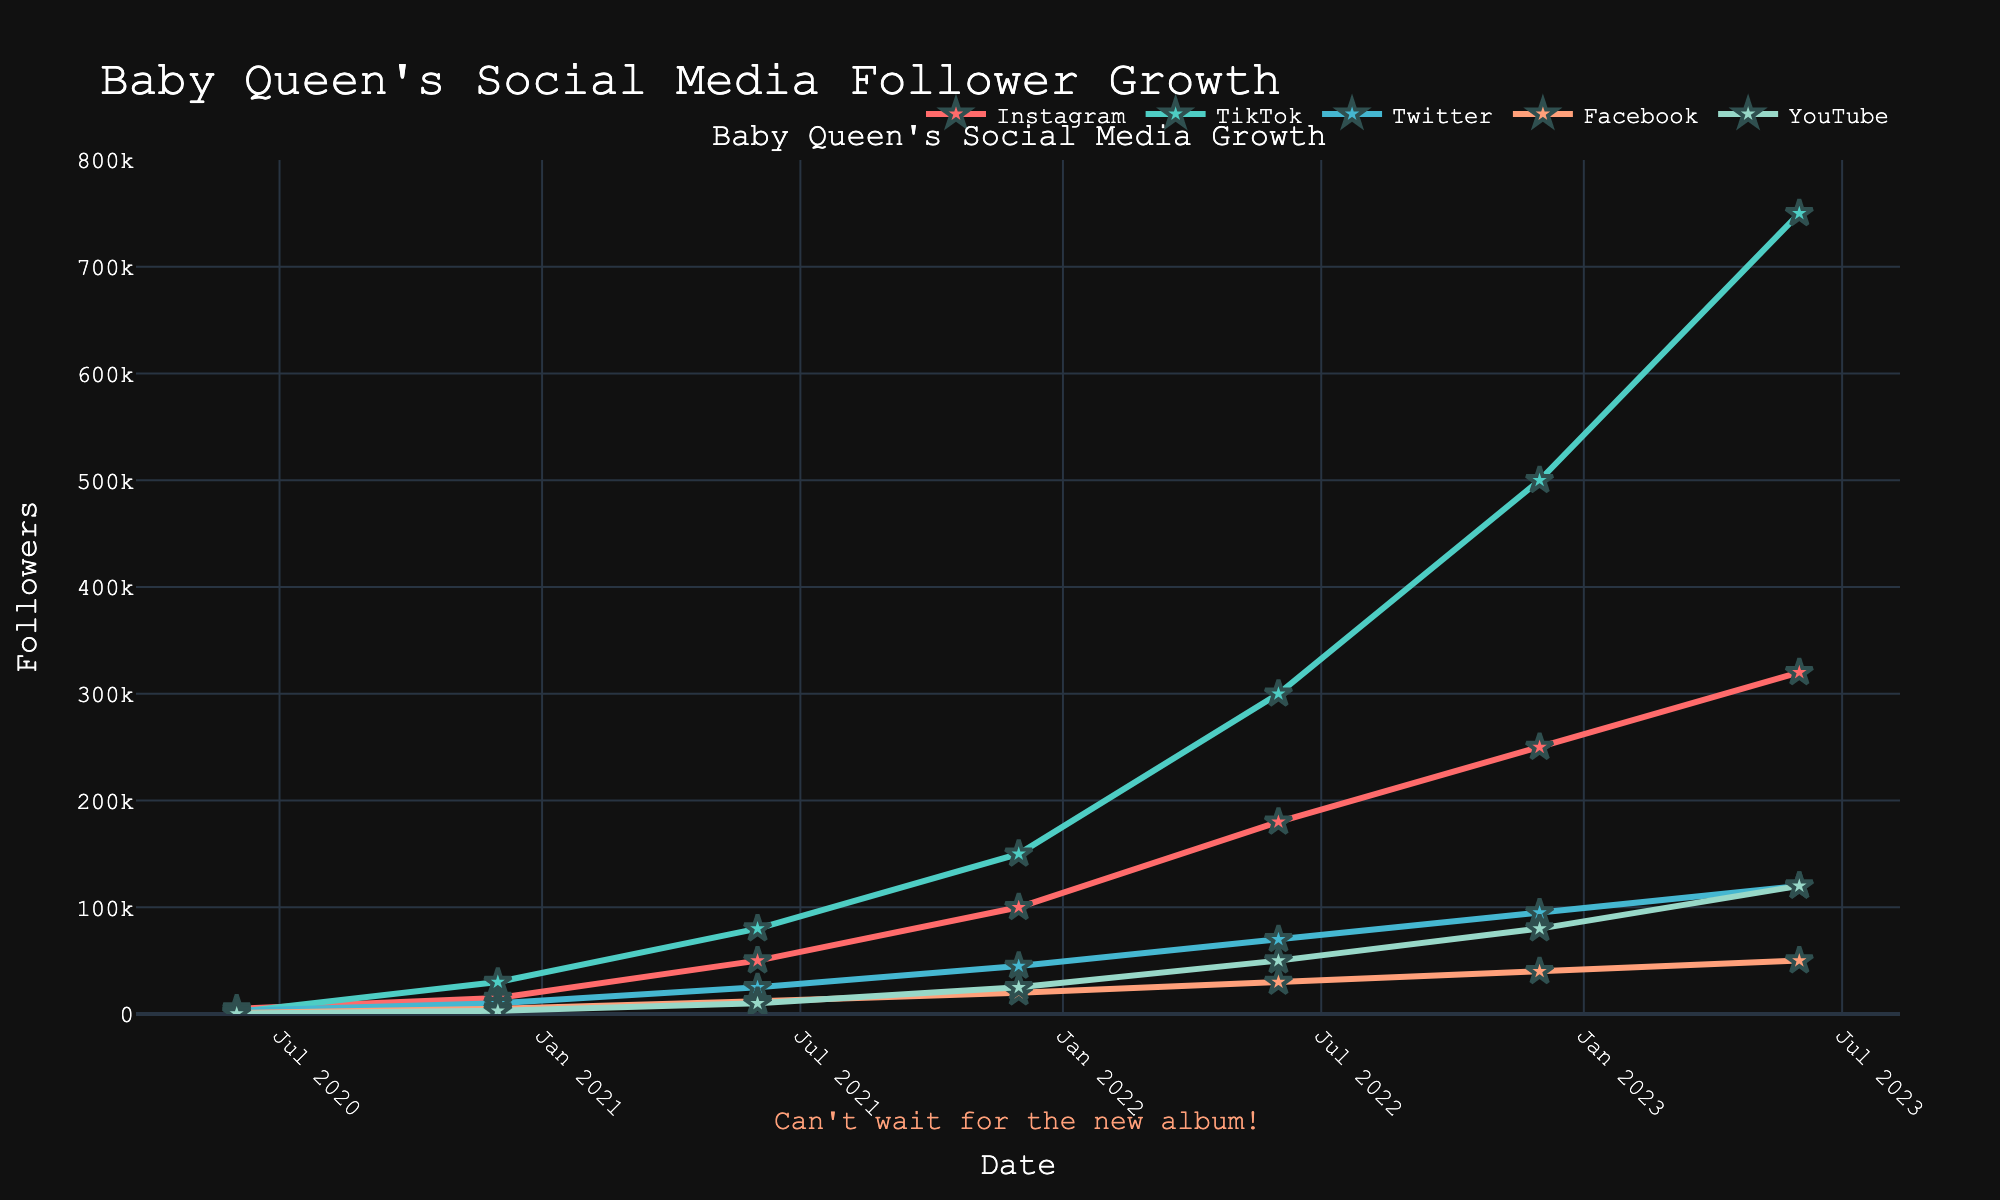which platform had the most followers by June 2023? Look at the endpoints of the lines in June 2023 and find which one is the highest. TikTok is at 750,000 followers, the highest among all.
Answer: TikTok how many new followers did YouTube gain from December 2020 to December 2022? Check the YouTube followers at both dates: 3,000 in December 2020 and 80,000 in December 2022. Subtract the initial count from the later count: 80,000 - 3,000.
Answer: 77,000 which social media platform saw the highest growth rate between December 2022 and June 2023? Compare the increase in followers for all platforms between these dates. TikTok's followers grew from 500,000 to 750,000, which is the largest increase.
Answer: TikTok calculate the average number of followers for Instagram over the total time period? Sum Instagram followers at all time points (5,000 + 15,000 + 50,000 + 100,000 + 180,000 + 250,000 + 320,000 = 920,000). There are 7 time points, so the average is 920,000 / 7.
Answer: 131,428.57 how did the follower count of Twitter in December 2021 compare to the follower count of Facebook in June 2022? Look at Twitter's followers in December 2021 (45,000) and Facebook's followers in June 2022 (30,000). Twitter's count is higher.
Answer: Twitter had more between June 2020 and June 2023, which platform had the least total growth in followers? Calculate the difference in followers from June 2020 to June 2023 for each platform. Facebook's growth is 50,000 - 1,000 = 49,000, the smallest among all platforms.
Answer: Facebook what was the total number of followers across all platforms in December 2022? Add the number of followers for each platform in December 2022 (250,000 + 500,000 + 95,000 + 40,000 + 80,000).
Answer: 965,000 compare the growth rates of Instagram and TikTok from June 2021 to December 2021. Which one grew faster? Calculate the increase for each platform: Instagram grew from 50,000 to 100,000 (50,000 new followers), TikTok grew from 80,000 to 150,000 (70,000 new followers). TikTok's increase is greater.
Answer: TikTok how has the gap between Instagram and YouTube followers evolved from June 2020 to June 2023? Subtract YouTube followers from Instagram followers at each date and see how the gap changes: 
June 2020: 5,000 - 500 = 4,500
June 2023: 320,000 - 120,000 = 200,000. The gap has significantly increased.
Answer: The gap increased 